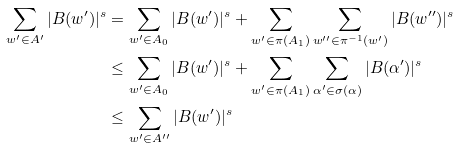Convert formula to latex. <formula><loc_0><loc_0><loc_500><loc_500>\sum _ { w ^ { \prime } \in A ^ { \prime } } | B ( w ^ { \prime } ) | ^ { s } & = \sum _ { w ^ { \prime } \in A _ { 0 } } | B ( w ^ { \prime } ) | ^ { s } + \sum _ { w ^ { \prime } \in \pi ( A _ { 1 } ) } \sum _ { w ^ { \prime \prime } \in \pi ^ { - 1 } ( w ^ { \prime } ) } | B ( w ^ { \prime \prime } ) | ^ { s } \\ & \leq \sum _ { w ^ { \prime } \in A _ { 0 } } | B ( w ^ { \prime } ) | ^ { s } + \sum _ { w ^ { \prime } \in \pi ( A _ { 1 } ) } \sum _ { \alpha ^ { \prime } \in \sigma ( \alpha ) } | B ( \alpha ^ { \prime } ) | ^ { s } \\ & \leq \sum _ { w ^ { \prime } \in A ^ { \prime \prime } } | B ( w ^ { \prime } ) | ^ { s }</formula> 